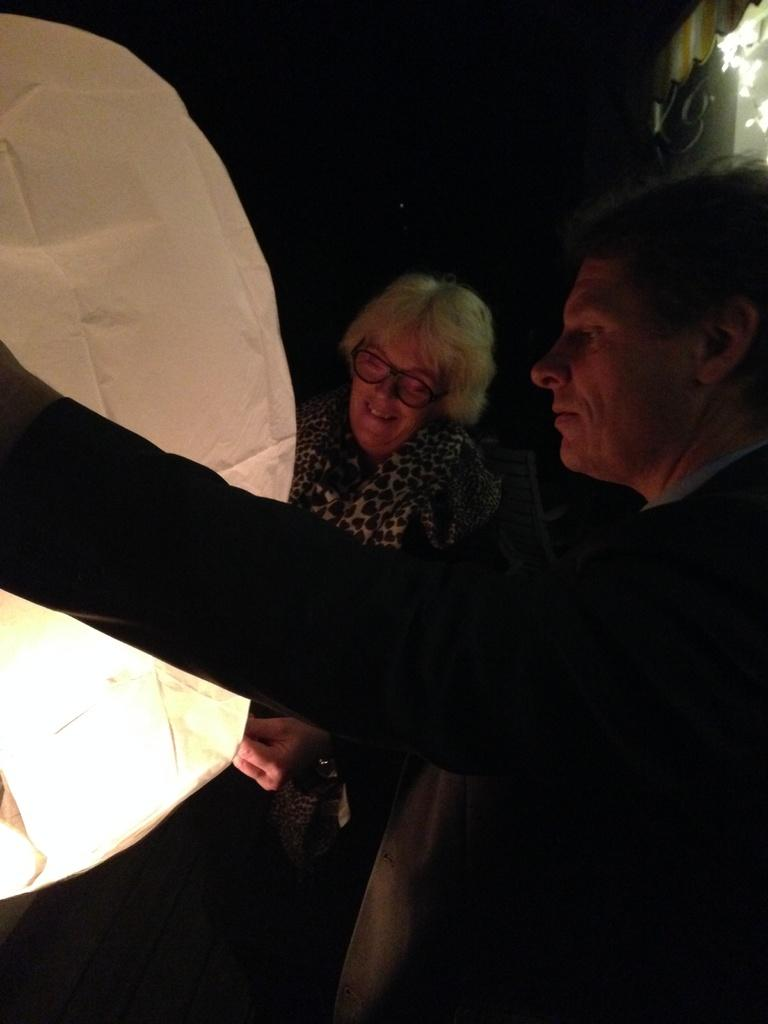How many people are present in the image? There are two people in the image, a man and a woman. What is the woman wearing in the image? The woman is wearing spectacles in the image. What object is the woman holding in the image? The woman is holding a paper lantern in the image. How many kittens are sitting on the man's head in the image? There are no kittens present in the image, and the man's head is not visible. 